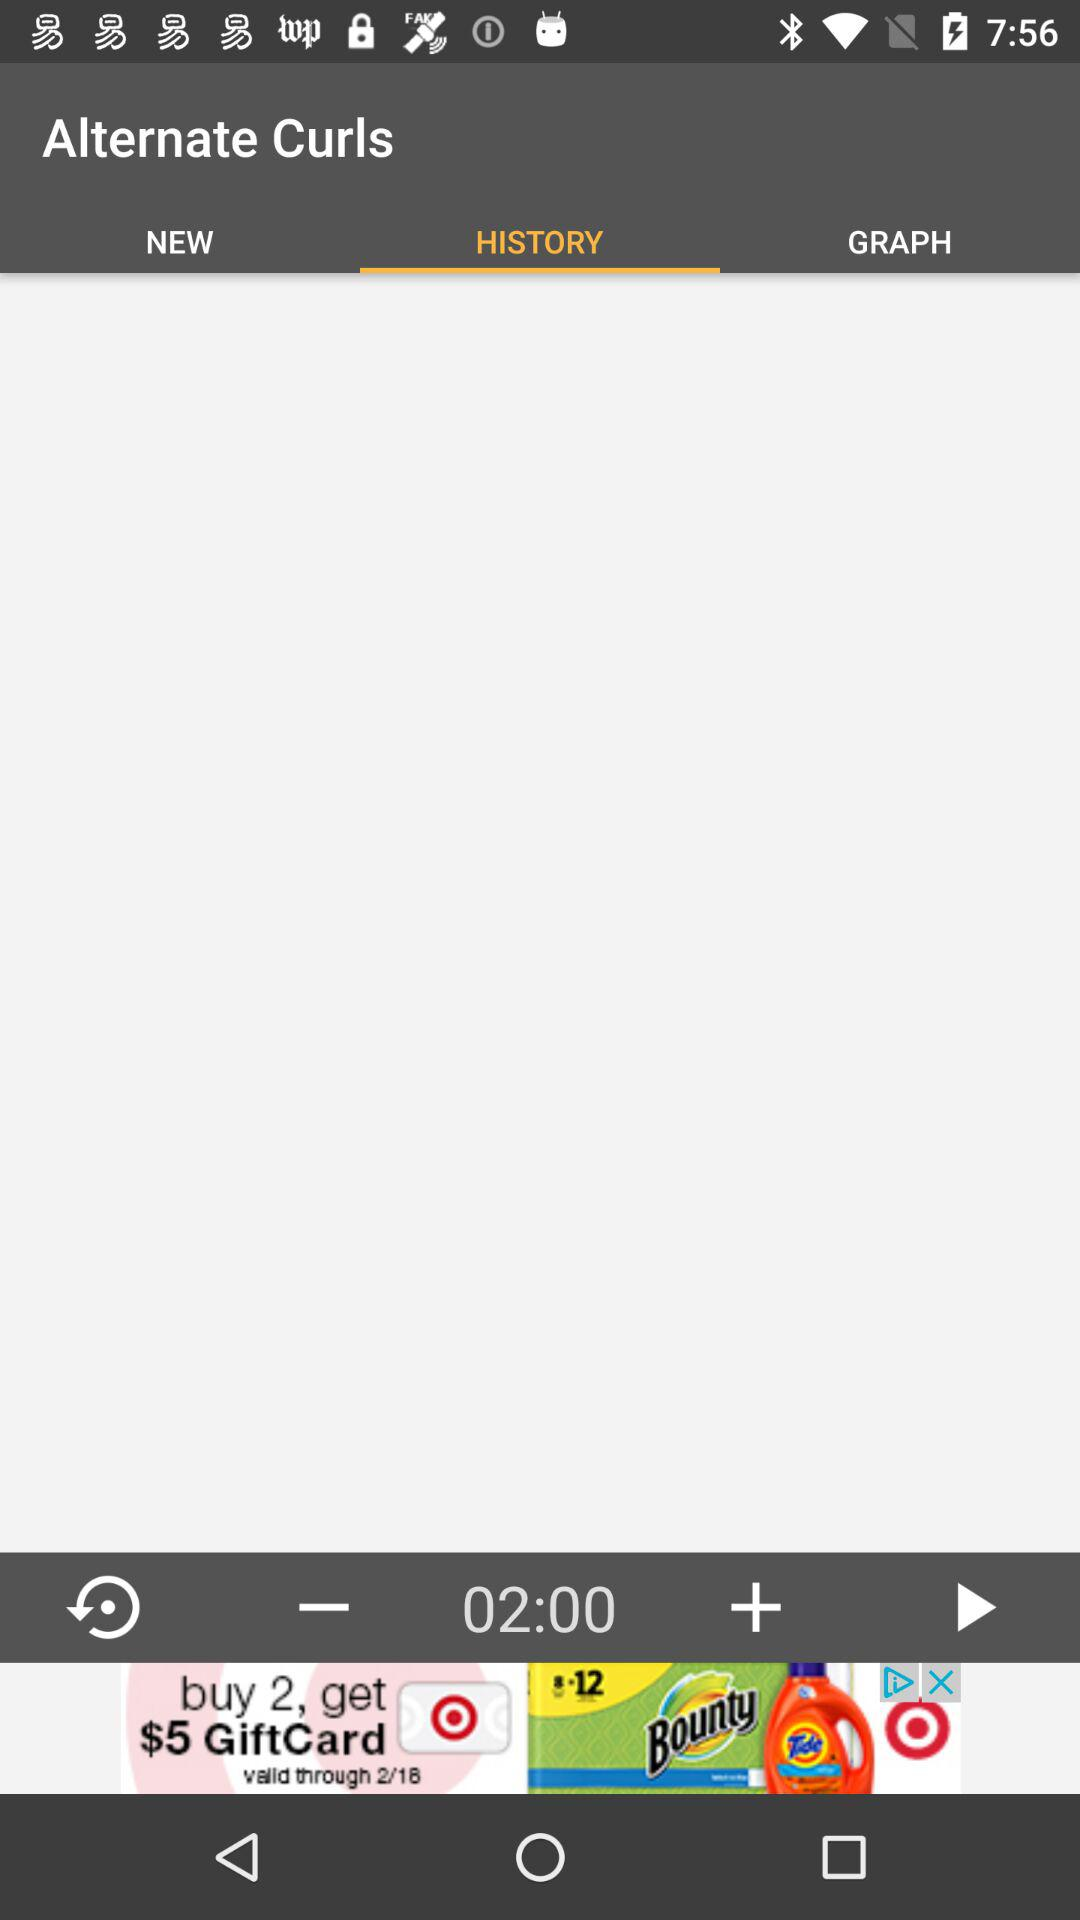Which tab is selected? The selected tab is "HISTORY". 